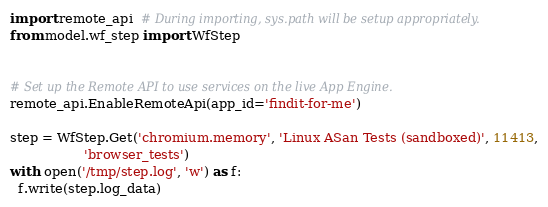Convert code to text. <code><loc_0><loc_0><loc_500><loc_500><_Python_>
import remote_api  # During importing, sys.path will be setup appropriately.
from model.wf_step import WfStep


# Set up the Remote API to use services on the live App Engine.
remote_api.EnableRemoteApi(app_id='findit-for-me')

step = WfStep.Get('chromium.memory', 'Linux ASan Tests (sandboxed)', 11413,
                  'browser_tests')
with open('/tmp/step.log', 'w') as f:
  f.write(step.log_data)
</code> 